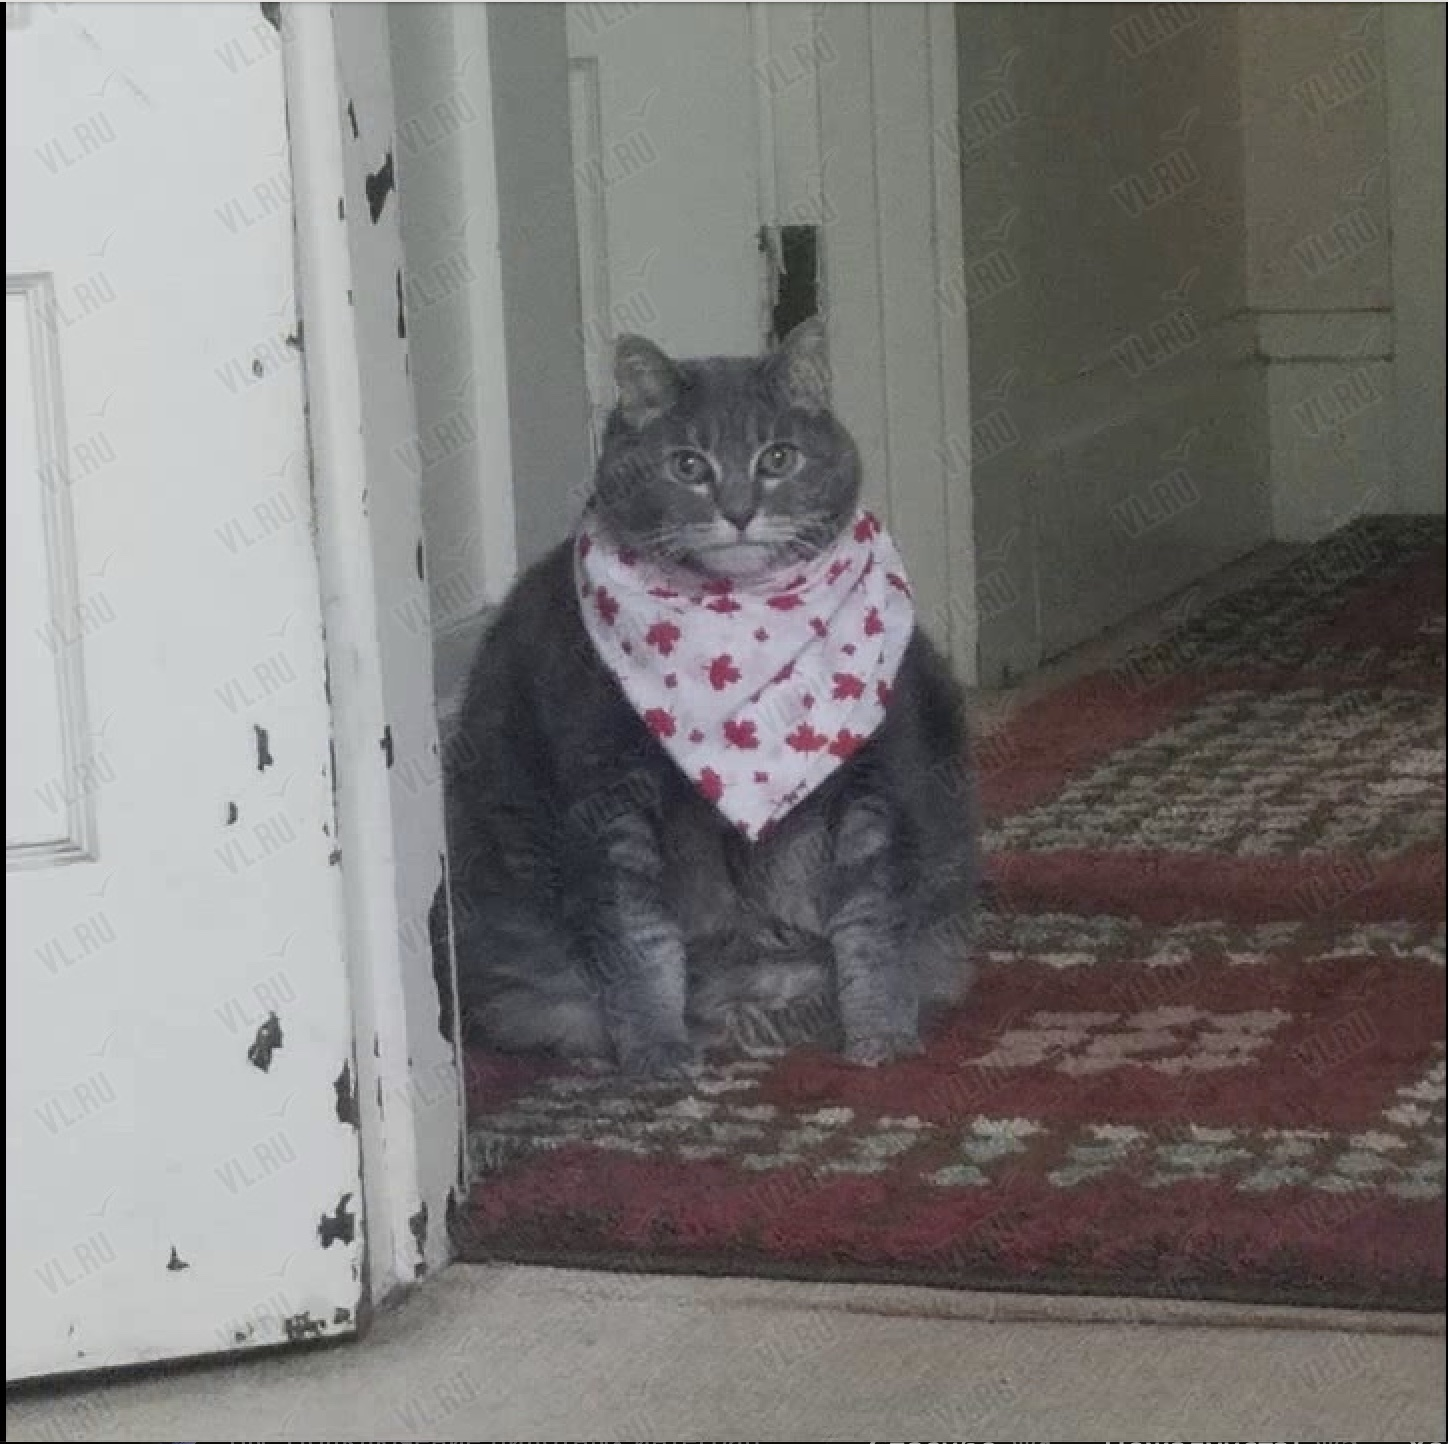Что изображено на фотографии? На фотографии изображена серая кошка с красным бантом, сидящая на красном ковре.  Кошка смотрит на камеру. 